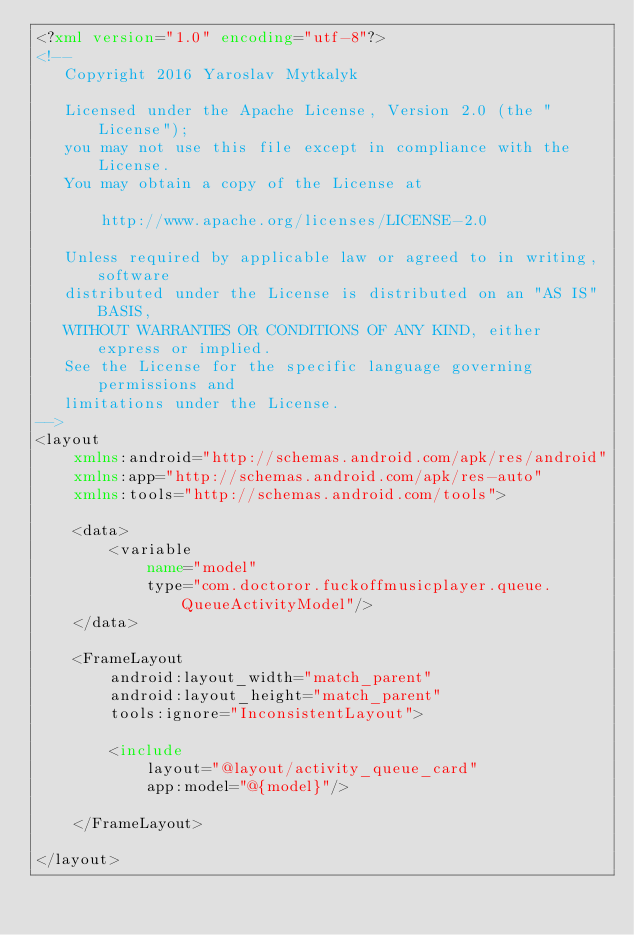Convert code to text. <code><loc_0><loc_0><loc_500><loc_500><_XML_><?xml version="1.0" encoding="utf-8"?>
<!--
   Copyright 2016 Yaroslav Mytkalyk

   Licensed under the Apache License, Version 2.0 (the "License");
   you may not use this file except in compliance with the License.
   You may obtain a copy of the License at

       http://www.apache.org/licenses/LICENSE-2.0

   Unless required by applicable law or agreed to in writing, software
   distributed under the License is distributed on an "AS IS" BASIS,
   WITHOUT WARRANTIES OR CONDITIONS OF ANY KIND, either express or implied.
   See the License for the specific language governing permissions and
   limitations under the License.
-->
<layout
    xmlns:android="http://schemas.android.com/apk/res/android"
    xmlns:app="http://schemas.android.com/apk/res-auto"
    xmlns:tools="http://schemas.android.com/tools">

    <data>
        <variable
            name="model"
            type="com.doctoror.fuckoffmusicplayer.queue.QueueActivityModel"/>
    </data>

    <FrameLayout
        android:layout_width="match_parent"
        android:layout_height="match_parent"
        tools:ignore="InconsistentLayout">

        <include
            layout="@layout/activity_queue_card"
            app:model="@{model}"/>

    </FrameLayout>

</layout></code> 